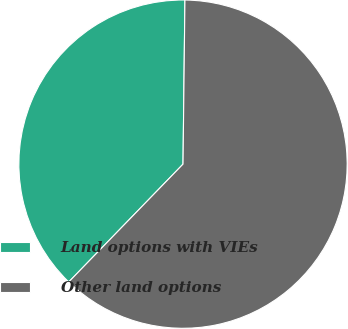<chart> <loc_0><loc_0><loc_500><loc_500><pie_chart><fcel>Land options with VIEs<fcel>Other land options<nl><fcel>37.93%<fcel>62.07%<nl></chart> 